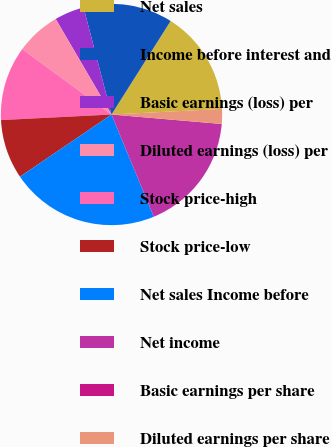<chart> <loc_0><loc_0><loc_500><loc_500><pie_chart><fcel>Net sales<fcel>Income before interest and<fcel>Basic earnings (loss) per<fcel>Diluted earnings (loss) per<fcel>Stock price-high<fcel>Stock price-low<fcel>Net sales Income before<fcel>Net income<fcel>Basic earnings per share<fcel>Diluted earnings per share<nl><fcel>15.22%<fcel>13.04%<fcel>4.35%<fcel>6.52%<fcel>10.87%<fcel>8.7%<fcel>21.74%<fcel>17.39%<fcel>0.0%<fcel>2.17%<nl></chart> 